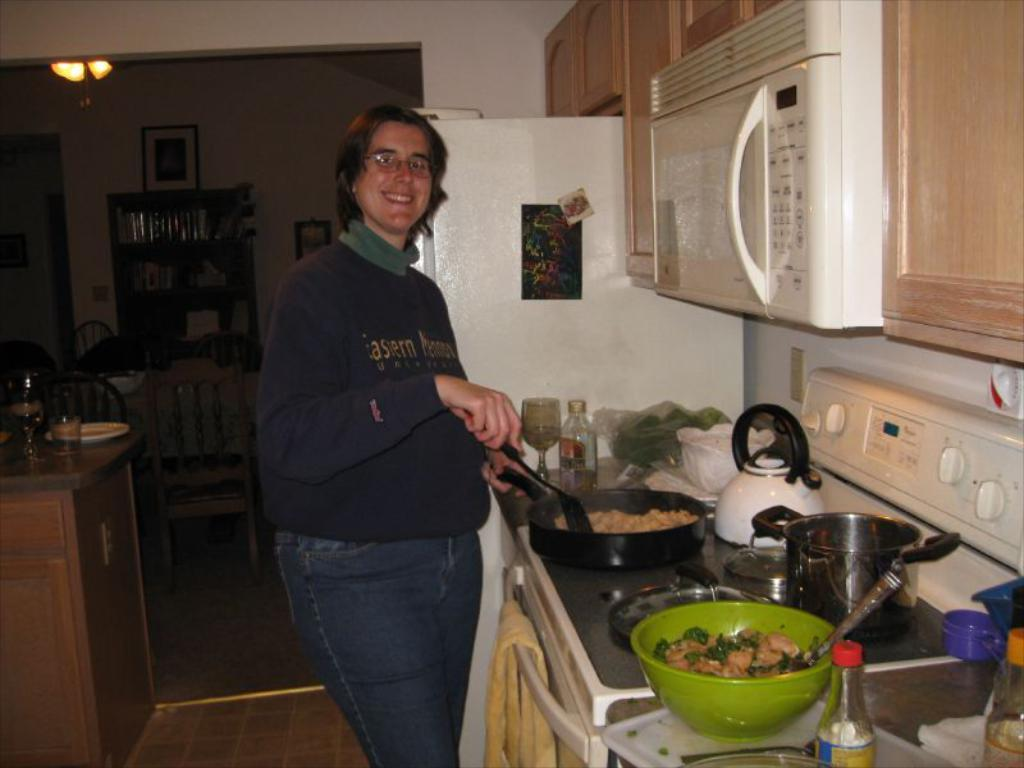<image>
Give a short and clear explanation of the subsequent image. A person cooking in the kitchen with a sweatshirt on has the word "Eastern" on it 